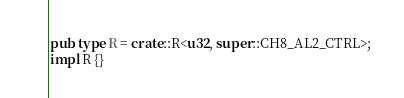<code> <loc_0><loc_0><loc_500><loc_500><_Rust_>pub type R = crate::R<u32, super::CH8_AL2_CTRL>;
impl R {}
</code> 